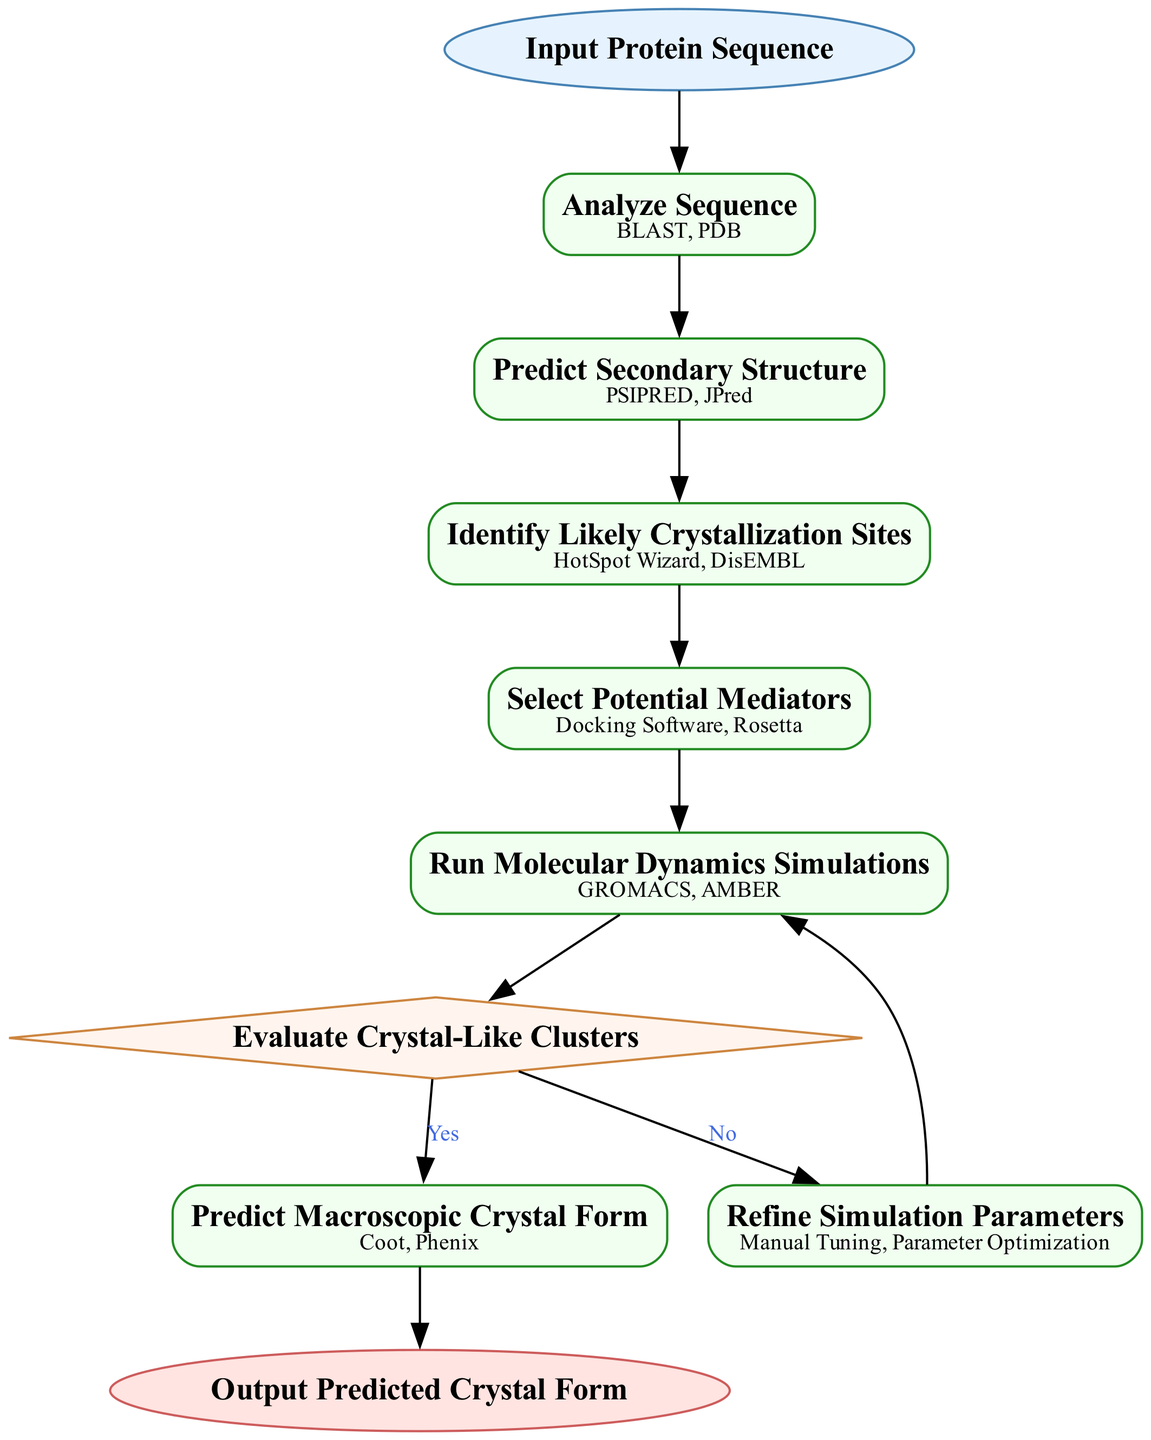What is the starting point of the flowchart? The flowchart begins with the node labeled "Input Protein Sequence," which indicates the initial step.
Answer: Input Protein Sequence How many process nodes are in the diagram? There are five process nodes that are clearly designated for different steps in the prediction pathway.
Answer: 5 Which node follows "Select Potential Mediators"? The node that comes after "Select Potential Mediators" is "Run Molecular Dynamics Simulations," indicating the next step in the process.
Answer: Run Molecular Dynamics Simulations What happens if the evaluation of crystal-like clusters is "Yes"? If the outcome of the evaluation is "Yes," the flowchart directs to the "Predict Macroscopic Crystal Form" node, leading to the prediction stage.
Answer: Predict Macroscopic Crystal Form What tools are listed for the "Analyze Sequence" step? The tools for the "Analyze Sequence" step are "BLAST" and "PDB," providing options for sequence analysis.
Answer: BLAST, PDB If the evaluation of crystal-like clusters is "No", what is the next step? When the decision is "No," it leads to the "Refine Simulation Parameters" step, implying a need for adjustments before re-evaluation.
Answer: Refine Simulation Parameters What is the final output of this flowchart? The flowchart concludes with the node "Output Predicted Crystal Form," which signifies the end of the process and represents the final predicted outcome.
Answer: Output Predicted Crystal Form How many decisions are represented in the diagram? There is one decision node in the flowchart that evaluates the crystal-like clusters, determining the subsequent steps based on its outcome.
Answer: 1 Which tools are used in the last prediction step? The tools for the last prediction step "Predict Macroscopic Crystal Form" are "Coot" and "Phenix," essential for macroscopic analysis.
Answer: Coot, Phenix 